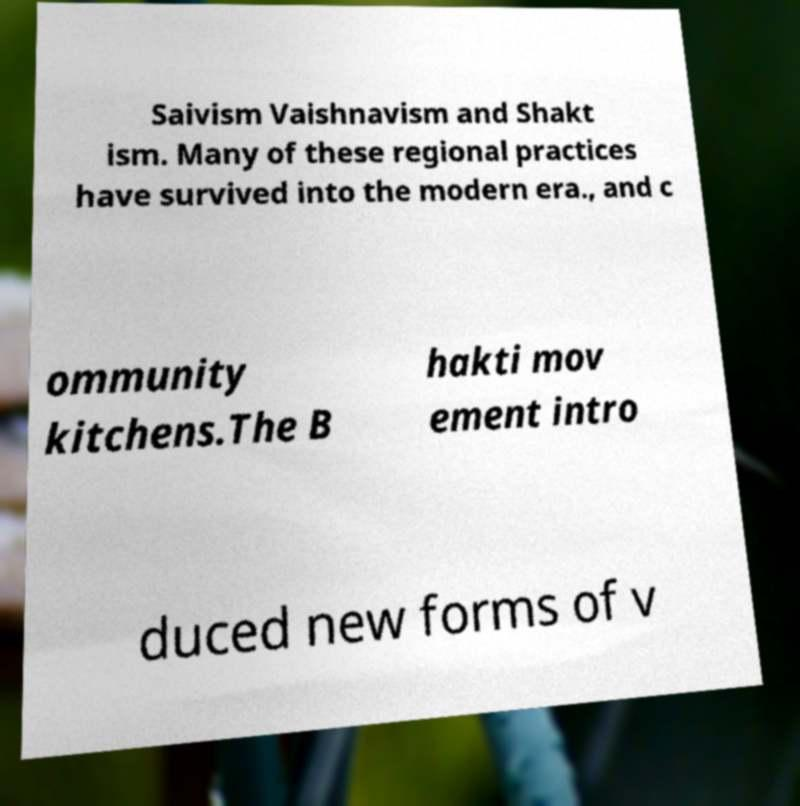There's text embedded in this image that I need extracted. Can you transcribe it verbatim? Saivism Vaishnavism and Shakt ism. Many of these regional practices have survived into the modern era., and c ommunity kitchens.The B hakti mov ement intro duced new forms of v 